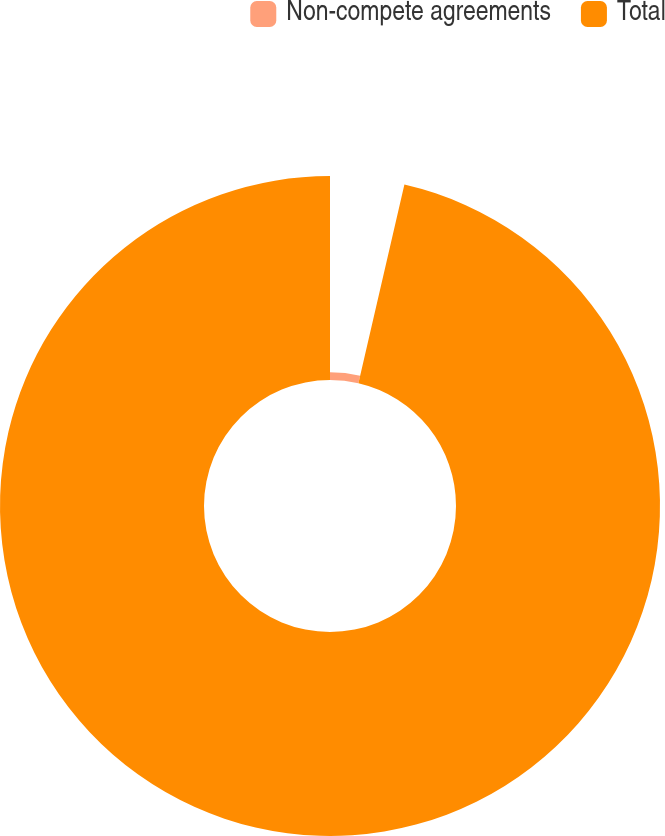Convert chart. <chart><loc_0><loc_0><loc_500><loc_500><pie_chart><fcel>Non-compete agreements<fcel>Total<nl><fcel>3.62%<fcel>96.38%<nl></chart> 